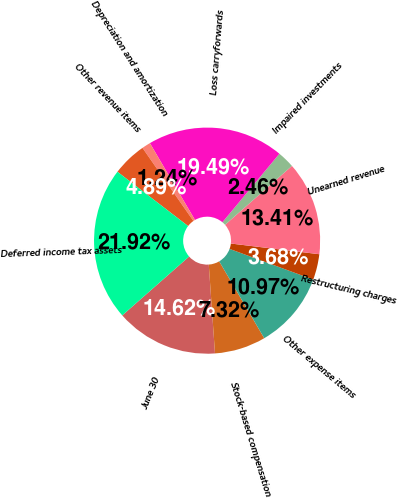<chart> <loc_0><loc_0><loc_500><loc_500><pie_chart><fcel>June 30<fcel>Stock-based compensation<fcel>Other expense items<fcel>Restructuring charges<fcel>Unearned revenue<fcel>Impaired investments<fcel>Loss carryforwards<fcel>Depreciation and amortization<fcel>Other revenue items<fcel>Deferred income tax assets<nl><fcel>14.62%<fcel>7.32%<fcel>10.97%<fcel>3.68%<fcel>13.41%<fcel>2.46%<fcel>19.49%<fcel>1.24%<fcel>4.89%<fcel>21.92%<nl></chart> 